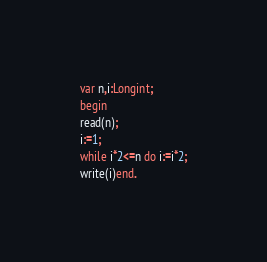Convert code to text. <code><loc_0><loc_0><loc_500><loc_500><_Pascal_>var n,i:Longint;
begin
read(n);
i:=1;
while i*2<=n do i:=i*2;
write(i)end.</code> 